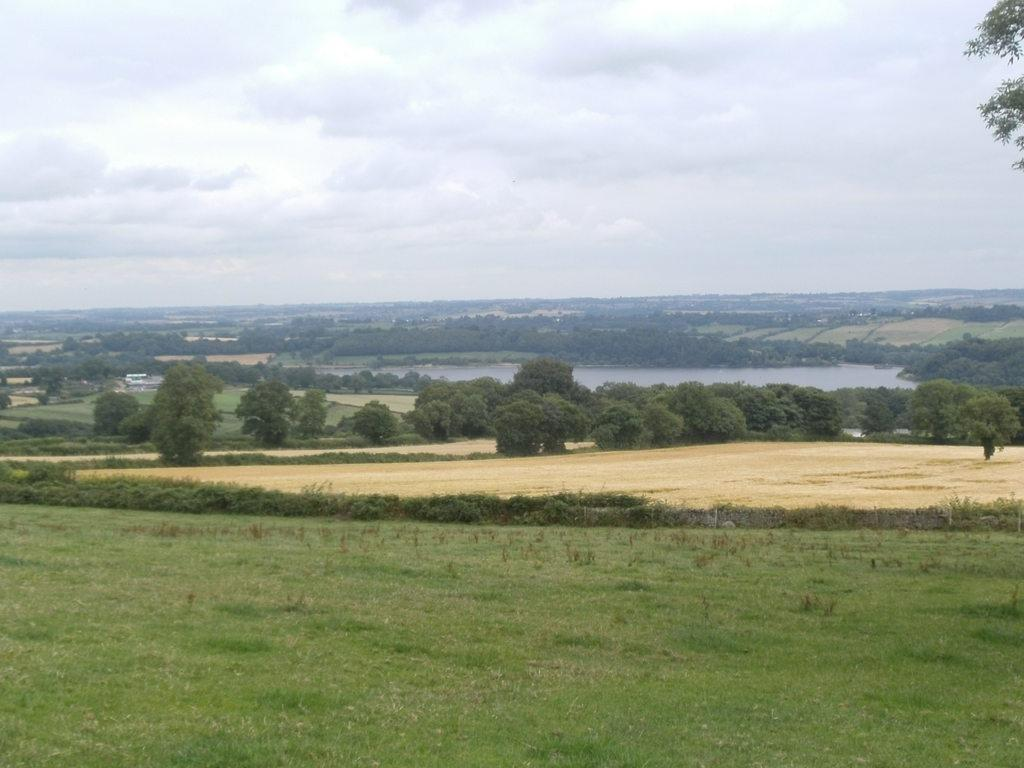What type of vegetation can be seen in the image? There are trees and plants in the image. What covers the ground in the image? There is grass on the ground in the image. What is visible in the image besides vegetation? There is water visible in the image. What is the condition of the sky in the image? The sky is cloudy in the image. How many fish can be seen swimming in the water in the image? There are no fish visible in the image; it only shows trees, plants, grass, water, and a cloudy sky. 